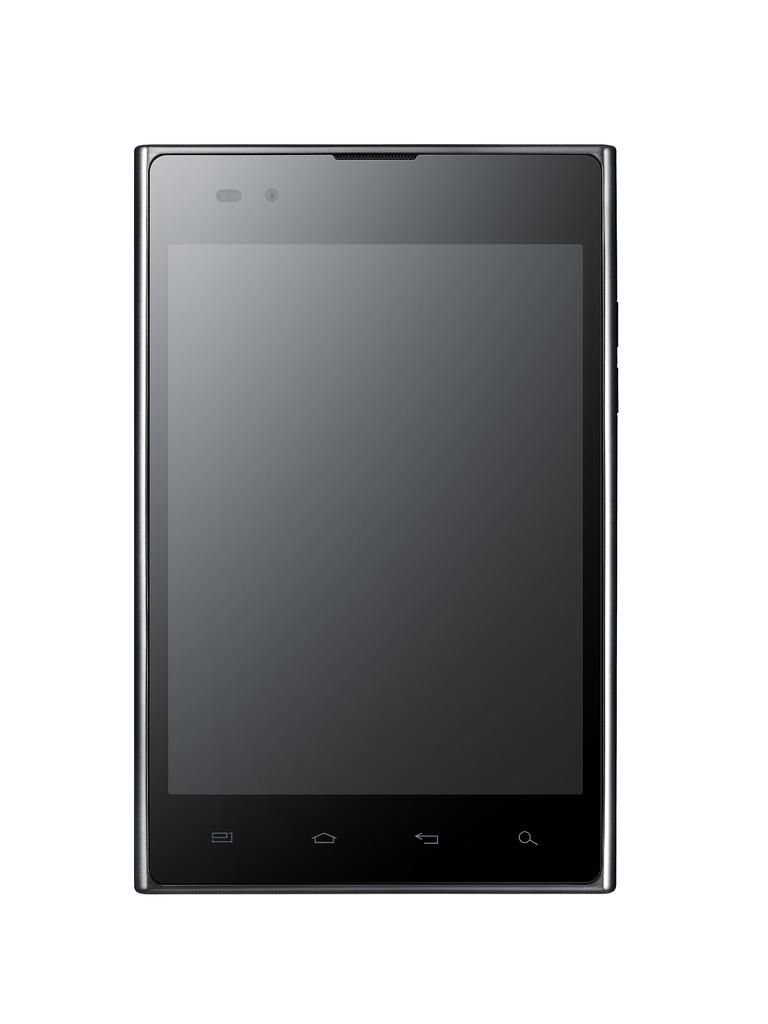What electronic device is present in the picture? There is a mobile phone in the picture. What is the color of the mobile phone? The mobile phone is black in color. What type of ship can be seen sailing in the background of the image? There is no ship present in the image; it only features a black mobile phone. 